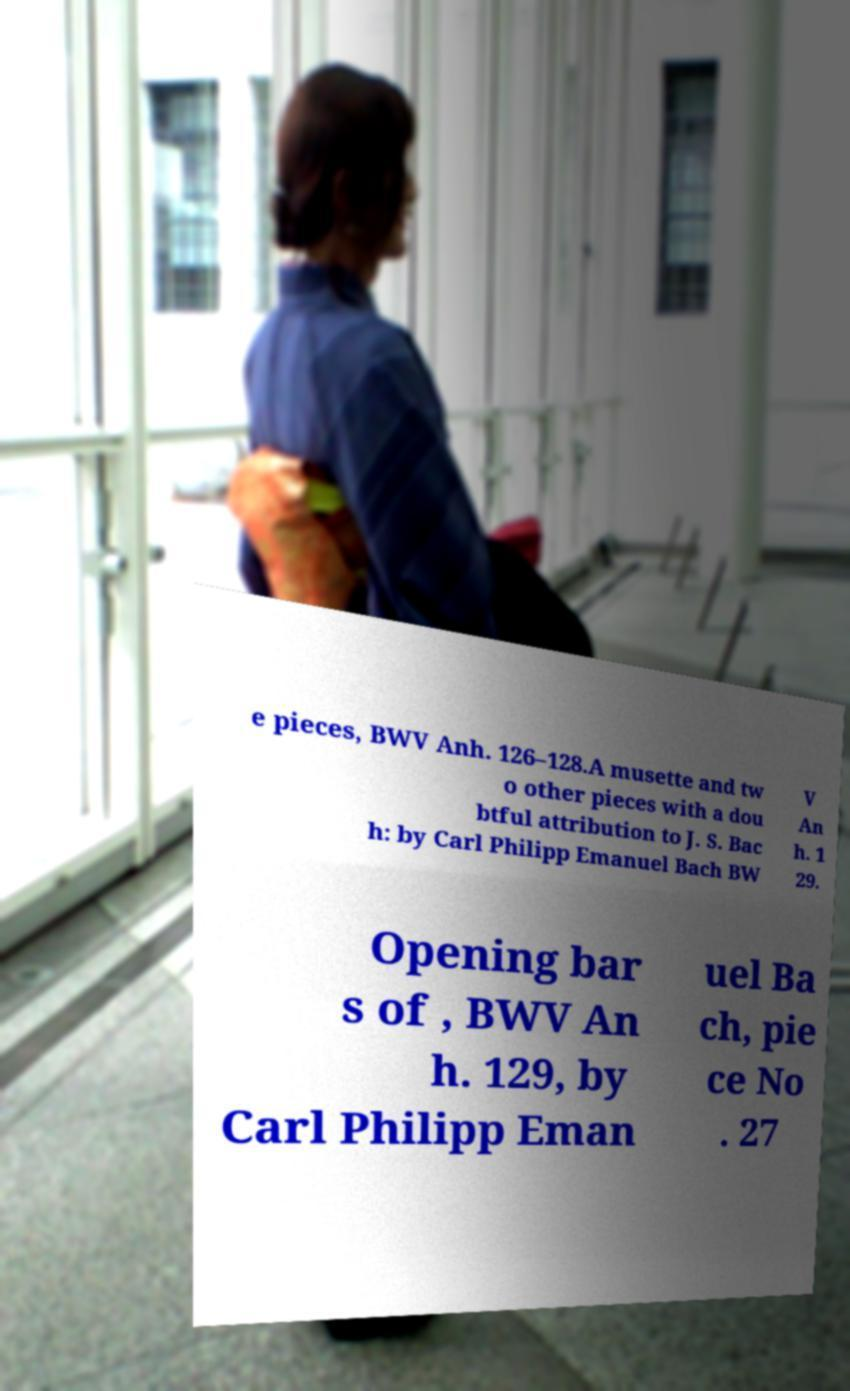Could you assist in decoding the text presented in this image and type it out clearly? e pieces, BWV Anh. 126–128.A musette and tw o other pieces with a dou btful attribution to J. S. Bac h: by Carl Philipp Emanuel Bach BW V An h. 1 29. Opening bar s of , BWV An h. 129, by Carl Philipp Eman uel Ba ch, pie ce No . 27 